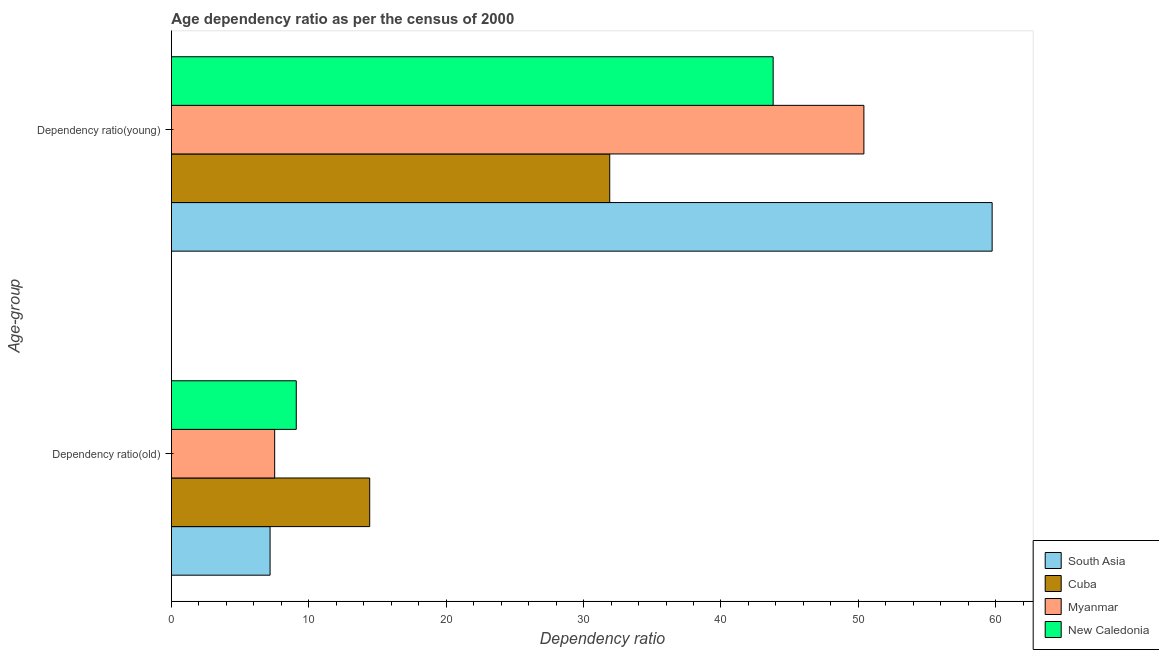How many groups of bars are there?
Keep it short and to the point. 2. Are the number of bars per tick equal to the number of legend labels?
Ensure brevity in your answer.  Yes. How many bars are there on the 1st tick from the top?
Offer a terse response. 4. How many bars are there on the 2nd tick from the bottom?
Provide a succinct answer. 4. What is the label of the 2nd group of bars from the top?
Give a very brief answer. Dependency ratio(old). What is the age dependency ratio(young) in Cuba?
Offer a terse response. 31.9. Across all countries, what is the maximum age dependency ratio(young)?
Your answer should be very brief. 59.73. Across all countries, what is the minimum age dependency ratio(old)?
Your response must be concise. 7.18. In which country was the age dependency ratio(young) minimum?
Provide a succinct answer. Cuba. What is the total age dependency ratio(young) in the graph?
Keep it short and to the point. 185.84. What is the difference between the age dependency ratio(young) in South Asia and that in Myanmar?
Your answer should be compact. 9.33. What is the difference between the age dependency ratio(old) in Myanmar and the age dependency ratio(young) in South Asia?
Your response must be concise. -52.22. What is the average age dependency ratio(old) per country?
Ensure brevity in your answer.  9.56. What is the difference between the age dependency ratio(young) and age dependency ratio(old) in Myanmar?
Keep it short and to the point. 42.88. What is the ratio of the age dependency ratio(old) in South Asia to that in Cuba?
Offer a very short reply. 0.5. In how many countries, is the age dependency ratio(young) greater than the average age dependency ratio(young) taken over all countries?
Give a very brief answer. 2. What does the 4th bar from the bottom in Dependency ratio(old) represents?
Your answer should be very brief. New Caledonia. Are all the bars in the graph horizontal?
Your response must be concise. Yes. How many countries are there in the graph?
Give a very brief answer. 4. What is the difference between two consecutive major ticks on the X-axis?
Offer a very short reply. 10. Does the graph contain any zero values?
Provide a succinct answer. No. Where does the legend appear in the graph?
Your answer should be very brief. Bottom right. What is the title of the graph?
Provide a short and direct response. Age dependency ratio as per the census of 2000. What is the label or title of the X-axis?
Ensure brevity in your answer.  Dependency ratio. What is the label or title of the Y-axis?
Keep it short and to the point. Age-group. What is the Dependency ratio in South Asia in Dependency ratio(old)?
Give a very brief answer. 7.18. What is the Dependency ratio of Cuba in Dependency ratio(old)?
Make the answer very short. 14.43. What is the Dependency ratio in Myanmar in Dependency ratio(old)?
Ensure brevity in your answer.  7.52. What is the Dependency ratio in New Caledonia in Dependency ratio(old)?
Offer a terse response. 9.09. What is the Dependency ratio of South Asia in Dependency ratio(young)?
Your answer should be very brief. 59.73. What is the Dependency ratio of Cuba in Dependency ratio(young)?
Give a very brief answer. 31.9. What is the Dependency ratio in Myanmar in Dependency ratio(young)?
Your response must be concise. 50.4. What is the Dependency ratio of New Caledonia in Dependency ratio(young)?
Provide a succinct answer. 43.8. Across all Age-group, what is the maximum Dependency ratio in South Asia?
Provide a short and direct response. 59.73. Across all Age-group, what is the maximum Dependency ratio in Cuba?
Your response must be concise. 31.9. Across all Age-group, what is the maximum Dependency ratio of Myanmar?
Offer a very short reply. 50.4. Across all Age-group, what is the maximum Dependency ratio in New Caledonia?
Your answer should be very brief. 43.8. Across all Age-group, what is the minimum Dependency ratio of South Asia?
Provide a succinct answer. 7.18. Across all Age-group, what is the minimum Dependency ratio in Cuba?
Ensure brevity in your answer.  14.43. Across all Age-group, what is the minimum Dependency ratio of Myanmar?
Your answer should be compact. 7.52. Across all Age-group, what is the minimum Dependency ratio in New Caledonia?
Offer a very short reply. 9.09. What is the total Dependency ratio of South Asia in the graph?
Offer a very short reply. 66.92. What is the total Dependency ratio in Cuba in the graph?
Offer a terse response. 46.34. What is the total Dependency ratio of Myanmar in the graph?
Your response must be concise. 57.92. What is the total Dependency ratio in New Caledonia in the graph?
Make the answer very short. 52.89. What is the difference between the Dependency ratio in South Asia in Dependency ratio(old) and that in Dependency ratio(young)?
Your response must be concise. -52.55. What is the difference between the Dependency ratio of Cuba in Dependency ratio(old) and that in Dependency ratio(young)?
Your response must be concise. -17.47. What is the difference between the Dependency ratio of Myanmar in Dependency ratio(old) and that in Dependency ratio(young)?
Give a very brief answer. -42.88. What is the difference between the Dependency ratio in New Caledonia in Dependency ratio(old) and that in Dependency ratio(young)?
Provide a short and direct response. -34.71. What is the difference between the Dependency ratio of South Asia in Dependency ratio(old) and the Dependency ratio of Cuba in Dependency ratio(young)?
Keep it short and to the point. -24.72. What is the difference between the Dependency ratio of South Asia in Dependency ratio(old) and the Dependency ratio of Myanmar in Dependency ratio(young)?
Your answer should be compact. -43.22. What is the difference between the Dependency ratio of South Asia in Dependency ratio(old) and the Dependency ratio of New Caledonia in Dependency ratio(young)?
Offer a terse response. -36.61. What is the difference between the Dependency ratio of Cuba in Dependency ratio(old) and the Dependency ratio of Myanmar in Dependency ratio(young)?
Offer a terse response. -35.97. What is the difference between the Dependency ratio in Cuba in Dependency ratio(old) and the Dependency ratio in New Caledonia in Dependency ratio(young)?
Your answer should be compact. -29.36. What is the difference between the Dependency ratio in Myanmar in Dependency ratio(old) and the Dependency ratio in New Caledonia in Dependency ratio(young)?
Keep it short and to the point. -36.28. What is the average Dependency ratio of South Asia per Age-group?
Offer a very short reply. 33.46. What is the average Dependency ratio of Cuba per Age-group?
Provide a short and direct response. 23.17. What is the average Dependency ratio in Myanmar per Age-group?
Ensure brevity in your answer.  28.96. What is the average Dependency ratio in New Caledonia per Age-group?
Provide a succinct answer. 26.44. What is the difference between the Dependency ratio in South Asia and Dependency ratio in Cuba in Dependency ratio(old)?
Offer a terse response. -7.25. What is the difference between the Dependency ratio in South Asia and Dependency ratio in Myanmar in Dependency ratio(old)?
Offer a terse response. -0.33. What is the difference between the Dependency ratio in South Asia and Dependency ratio in New Caledonia in Dependency ratio(old)?
Your answer should be very brief. -1.91. What is the difference between the Dependency ratio of Cuba and Dependency ratio of Myanmar in Dependency ratio(old)?
Ensure brevity in your answer.  6.92. What is the difference between the Dependency ratio in Cuba and Dependency ratio in New Caledonia in Dependency ratio(old)?
Make the answer very short. 5.34. What is the difference between the Dependency ratio of Myanmar and Dependency ratio of New Caledonia in Dependency ratio(old)?
Provide a short and direct response. -1.57. What is the difference between the Dependency ratio of South Asia and Dependency ratio of Cuba in Dependency ratio(young)?
Make the answer very short. 27.83. What is the difference between the Dependency ratio in South Asia and Dependency ratio in Myanmar in Dependency ratio(young)?
Your response must be concise. 9.33. What is the difference between the Dependency ratio in South Asia and Dependency ratio in New Caledonia in Dependency ratio(young)?
Your answer should be very brief. 15.94. What is the difference between the Dependency ratio of Cuba and Dependency ratio of Myanmar in Dependency ratio(young)?
Provide a short and direct response. -18.5. What is the difference between the Dependency ratio of Cuba and Dependency ratio of New Caledonia in Dependency ratio(young)?
Provide a short and direct response. -11.89. What is the difference between the Dependency ratio of Myanmar and Dependency ratio of New Caledonia in Dependency ratio(young)?
Make the answer very short. 6.6. What is the ratio of the Dependency ratio in South Asia in Dependency ratio(old) to that in Dependency ratio(young)?
Provide a succinct answer. 0.12. What is the ratio of the Dependency ratio of Cuba in Dependency ratio(old) to that in Dependency ratio(young)?
Keep it short and to the point. 0.45. What is the ratio of the Dependency ratio in Myanmar in Dependency ratio(old) to that in Dependency ratio(young)?
Provide a succinct answer. 0.15. What is the ratio of the Dependency ratio in New Caledonia in Dependency ratio(old) to that in Dependency ratio(young)?
Give a very brief answer. 0.21. What is the difference between the highest and the second highest Dependency ratio in South Asia?
Keep it short and to the point. 52.55. What is the difference between the highest and the second highest Dependency ratio of Cuba?
Your answer should be compact. 17.47. What is the difference between the highest and the second highest Dependency ratio of Myanmar?
Offer a terse response. 42.88. What is the difference between the highest and the second highest Dependency ratio in New Caledonia?
Keep it short and to the point. 34.71. What is the difference between the highest and the lowest Dependency ratio in South Asia?
Keep it short and to the point. 52.55. What is the difference between the highest and the lowest Dependency ratio in Cuba?
Your response must be concise. 17.47. What is the difference between the highest and the lowest Dependency ratio of Myanmar?
Give a very brief answer. 42.88. What is the difference between the highest and the lowest Dependency ratio in New Caledonia?
Offer a terse response. 34.71. 